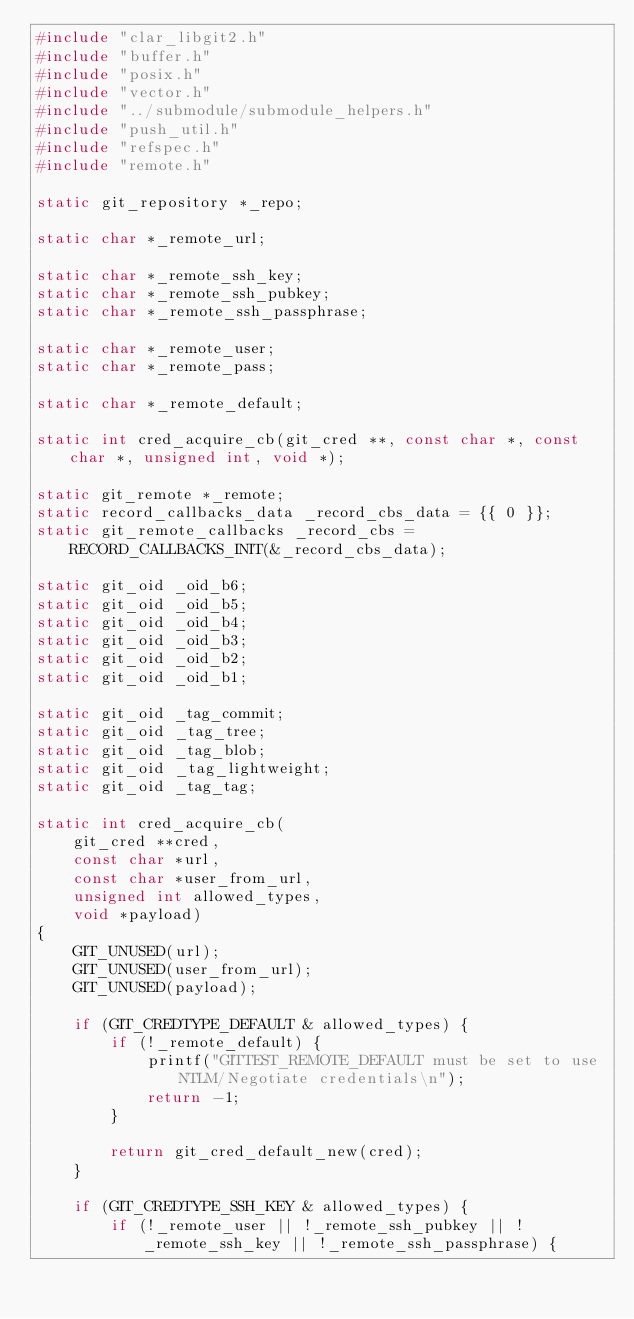Convert code to text. <code><loc_0><loc_0><loc_500><loc_500><_C_>#include "clar_libgit2.h"
#include "buffer.h"
#include "posix.h"
#include "vector.h"
#include "../submodule/submodule_helpers.h"
#include "push_util.h"
#include "refspec.h"
#include "remote.h"

static git_repository *_repo;

static char *_remote_url;

static char *_remote_ssh_key;
static char *_remote_ssh_pubkey;
static char *_remote_ssh_passphrase;

static char *_remote_user;
static char *_remote_pass;

static char *_remote_default;

static int cred_acquire_cb(git_cred **,	const char *, const char *, unsigned int, void *);

static git_remote *_remote;
static record_callbacks_data _record_cbs_data = {{ 0 }};
static git_remote_callbacks _record_cbs = RECORD_CALLBACKS_INIT(&_record_cbs_data);

static git_oid _oid_b6;
static git_oid _oid_b5;
static git_oid _oid_b4;
static git_oid _oid_b3;
static git_oid _oid_b2;
static git_oid _oid_b1;

static git_oid _tag_commit;
static git_oid _tag_tree;
static git_oid _tag_blob;
static git_oid _tag_lightweight;
static git_oid _tag_tag;

static int cred_acquire_cb(
	git_cred **cred,
	const char *url,
	const char *user_from_url,
	unsigned int allowed_types,
	void *payload)
{
	GIT_UNUSED(url);
	GIT_UNUSED(user_from_url);
	GIT_UNUSED(payload);

	if (GIT_CREDTYPE_DEFAULT & allowed_types) {
		if (!_remote_default) {
			printf("GITTEST_REMOTE_DEFAULT must be set to use NTLM/Negotiate credentials\n");
			return -1;
		}

		return git_cred_default_new(cred);
	}

	if (GIT_CREDTYPE_SSH_KEY & allowed_types) {
		if (!_remote_user || !_remote_ssh_pubkey || !_remote_ssh_key || !_remote_ssh_passphrase) {</code> 